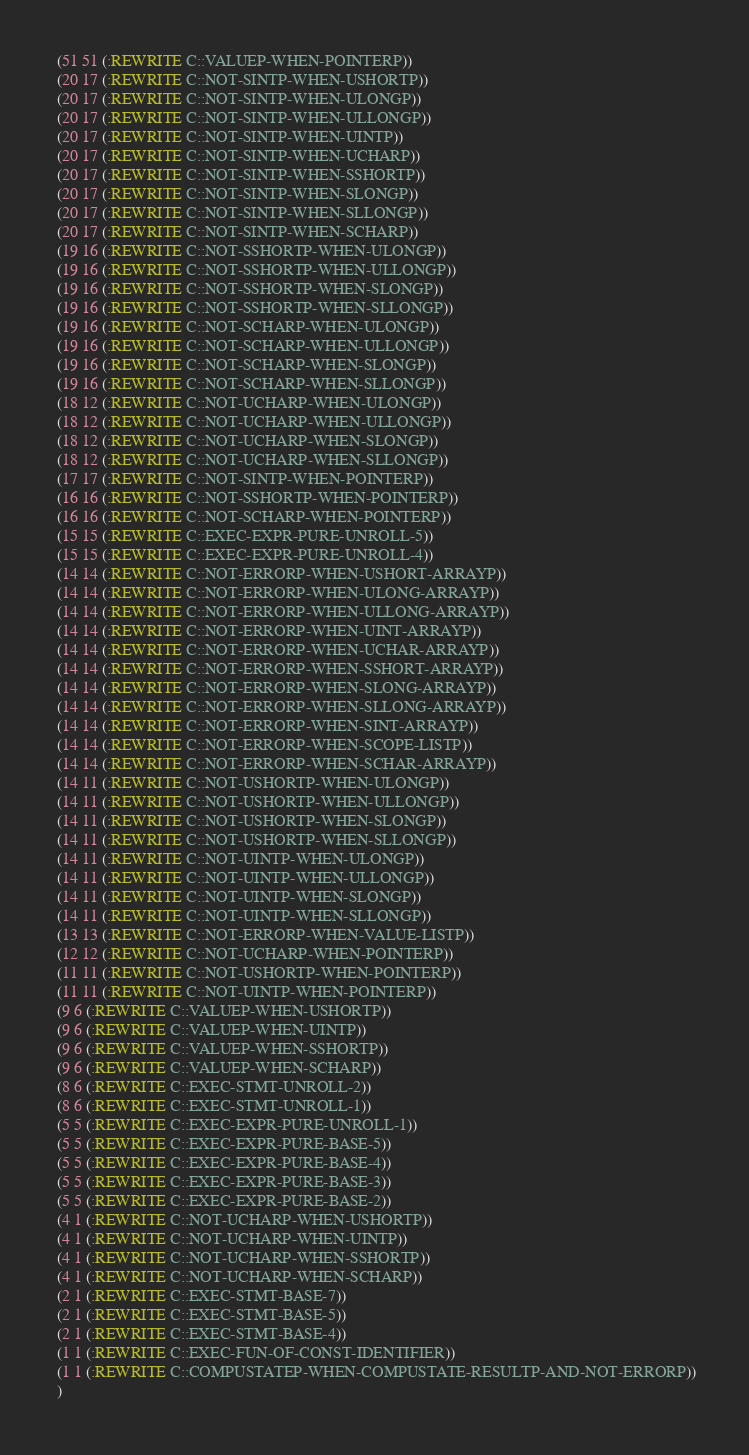<code> <loc_0><loc_0><loc_500><loc_500><_Lisp_> (51 51 (:REWRITE C::VALUEP-WHEN-POINTERP))
 (20 17 (:REWRITE C::NOT-SINTP-WHEN-USHORTP))
 (20 17 (:REWRITE C::NOT-SINTP-WHEN-ULONGP))
 (20 17 (:REWRITE C::NOT-SINTP-WHEN-ULLONGP))
 (20 17 (:REWRITE C::NOT-SINTP-WHEN-UINTP))
 (20 17 (:REWRITE C::NOT-SINTP-WHEN-UCHARP))
 (20 17 (:REWRITE C::NOT-SINTP-WHEN-SSHORTP))
 (20 17 (:REWRITE C::NOT-SINTP-WHEN-SLONGP))
 (20 17 (:REWRITE C::NOT-SINTP-WHEN-SLLONGP))
 (20 17 (:REWRITE C::NOT-SINTP-WHEN-SCHARP))
 (19 16 (:REWRITE C::NOT-SSHORTP-WHEN-ULONGP))
 (19 16 (:REWRITE C::NOT-SSHORTP-WHEN-ULLONGP))
 (19 16 (:REWRITE C::NOT-SSHORTP-WHEN-SLONGP))
 (19 16 (:REWRITE C::NOT-SSHORTP-WHEN-SLLONGP))
 (19 16 (:REWRITE C::NOT-SCHARP-WHEN-ULONGP))
 (19 16 (:REWRITE C::NOT-SCHARP-WHEN-ULLONGP))
 (19 16 (:REWRITE C::NOT-SCHARP-WHEN-SLONGP))
 (19 16 (:REWRITE C::NOT-SCHARP-WHEN-SLLONGP))
 (18 12 (:REWRITE C::NOT-UCHARP-WHEN-ULONGP))
 (18 12 (:REWRITE C::NOT-UCHARP-WHEN-ULLONGP))
 (18 12 (:REWRITE C::NOT-UCHARP-WHEN-SLONGP))
 (18 12 (:REWRITE C::NOT-UCHARP-WHEN-SLLONGP))
 (17 17 (:REWRITE C::NOT-SINTP-WHEN-POINTERP))
 (16 16 (:REWRITE C::NOT-SSHORTP-WHEN-POINTERP))
 (16 16 (:REWRITE C::NOT-SCHARP-WHEN-POINTERP))
 (15 15 (:REWRITE C::EXEC-EXPR-PURE-UNROLL-5))
 (15 15 (:REWRITE C::EXEC-EXPR-PURE-UNROLL-4))
 (14 14 (:REWRITE C::NOT-ERRORP-WHEN-USHORT-ARRAYP))
 (14 14 (:REWRITE C::NOT-ERRORP-WHEN-ULONG-ARRAYP))
 (14 14 (:REWRITE C::NOT-ERRORP-WHEN-ULLONG-ARRAYP))
 (14 14 (:REWRITE C::NOT-ERRORP-WHEN-UINT-ARRAYP))
 (14 14 (:REWRITE C::NOT-ERRORP-WHEN-UCHAR-ARRAYP))
 (14 14 (:REWRITE C::NOT-ERRORP-WHEN-SSHORT-ARRAYP))
 (14 14 (:REWRITE C::NOT-ERRORP-WHEN-SLONG-ARRAYP))
 (14 14 (:REWRITE C::NOT-ERRORP-WHEN-SLLONG-ARRAYP))
 (14 14 (:REWRITE C::NOT-ERRORP-WHEN-SINT-ARRAYP))
 (14 14 (:REWRITE C::NOT-ERRORP-WHEN-SCOPE-LISTP))
 (14 14 (:REWRITE C::NOT-ERRORP-WHEN-SCHAR-ARRAYP))
 (14 11 (:REWRITE C::NOT-USHORTP-WHEN-ULONGP))
 (14 11 (:REWRITE C::NOT-USHORTP-WHEN-ULLONGP))
 (14 11 (:REWRITE C::NOT-USHORTP-WHEN-SLONGP))
 (14 11 (:REWRITE C::NOT-USHORTP-WHEN-SLLONGP))
 (14 11 (:REWRITE C::NOT-UINTP-WHEN-ULONGP))
 (14 11 (:REWRITE C::NOT-UINTP-WHEN-ULLONGP))
 (14 11 (:REWRITE C::NOT-UINTP-WHEN-SLONGP))
 (14 11 (:REWRITE C::NOT-UINTP-WHEN-SLLONGP))
 (13 13 (:REWRITE C::NOT-ERRORP-WHEN-VALUE-LISTP))
 (12 12 (:REWRITE C::NOT-UCHARP-WHEN-POINTERP))
 (11 11 (:REWRITE C::NOT-USHORTP-WHEN-POINTERP))
 (11 11 (:REWRITE C::NOT-UINTP-WHEN-POINTERP))
 (9 6 (:REWRITE C::VALUEP-WHEN-USHORTP))
 (9 6 (:REWRITE C::VALUEP-WHEN-UINTP))
 (9 6 (:REWRITE C::VALUEP-WHEN-SSHORTP))
 (9 6 (:REWRITE C::VALUEP-WHEN-SCHARP))
 (8 6 (:REWRITE C::EXEC-STMT-UNROLL-2))
 (8 6 (:REWRITE C::EXEC-STMT-UNROLL-1))
 (5 5 (:REWRITE C::EXEC-EXPR-PURE-UNROLL-1))
 (5 5 (:REWRITE C::EXEC-EXPR-PURE-BASE-5))
 (5 5 (:REWRITE C::EXEC-EXPR-PURE-BASE-4))
 (5 5 (:REWRITE C::EXEC-EXPR-PURE-BASE-3))
 (5 5 (:REWRITE C::EXEC-EXPR-PURE-BASE-2))
 (4 1 (:REWRITE C::NOT-UCHARP-WHEN-USHORTP))
 (4 1 (:REWRITE C::NOT-UCHARP-WHEN-UINTP))
 (4 1 (:REWRITE C::NOT-UCHARP-WHEN-SSHORTP))
 (4 1 (:REWRITE C::NOT-UCHARP-WHEN-SCHARP))
 (2 1 (:REWRITE C::EXEC-STMT-BASE-7))
 (2 1 (:REWRITE C::EXEC-STMT-BASE-5))
 (2 1 (:REWRITE C::EXEC-STMT-BASE-4))
 (1 1 (:REWRITE C::EXEC-FUN-OF-CONST-IDENTIFIER))
 (1 1 (:REWRITE C::COMPUSTATEP-WHEN-COMPUSTATE-RESULTP-AND-NOT-ERRORP))
 )
</code> 